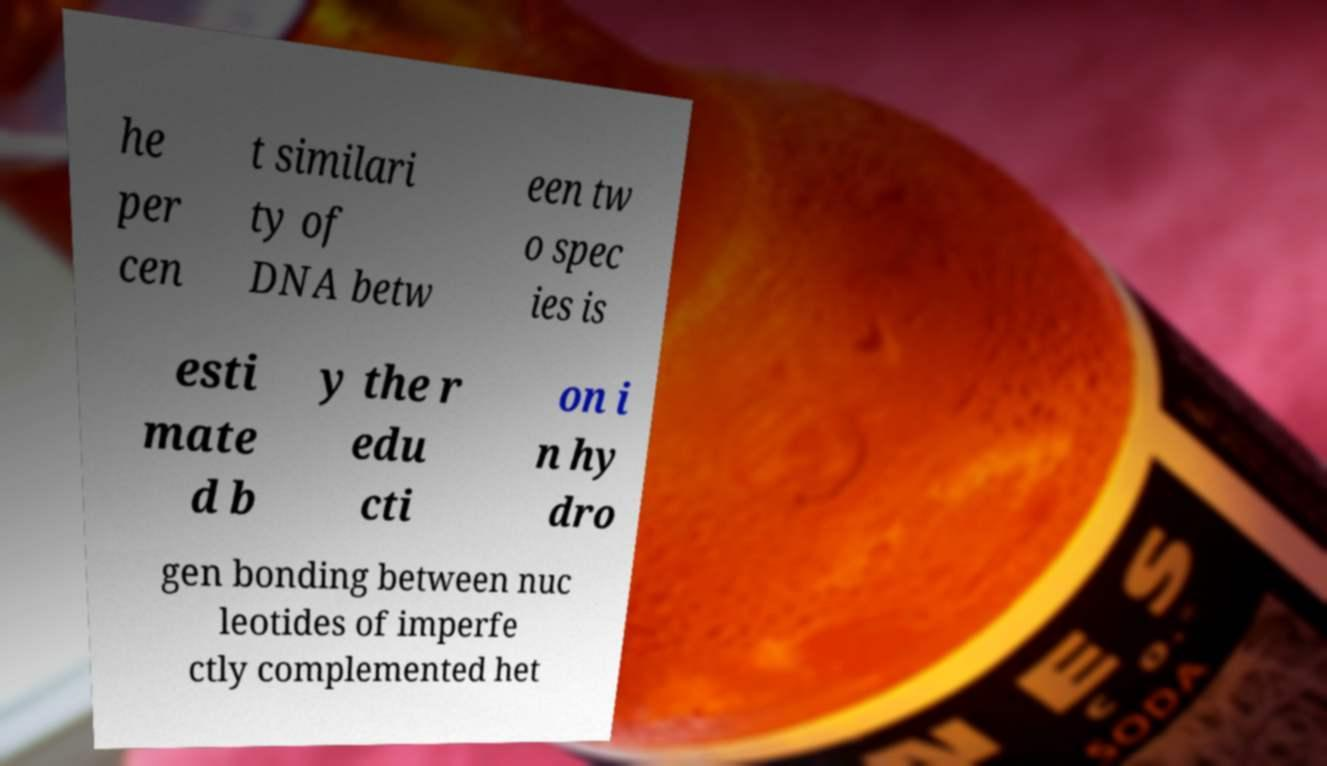Can you read and provide the text displayed in the image?This photo seems to have some interesting text. Can you extract and type it out for me? he per cen t similari ty of DNA betw een tw o spec ies is esti mate d b y the r edu cti on i n hy dro gen bonding between nuc leotides of imperfe ctly complemented het 